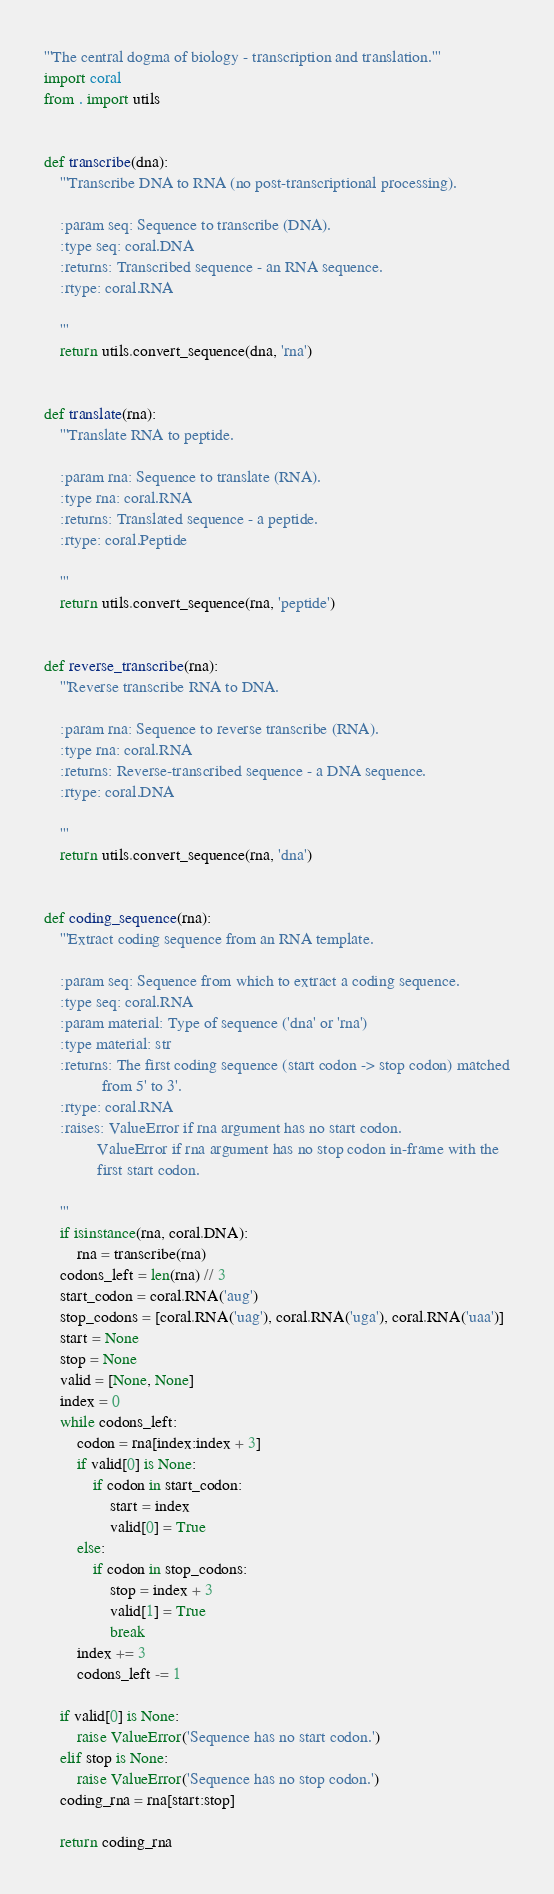<code> <loc_0><loc_0><loc_500><loc_500><_Python_>'''The central dogma of biology - transcription and translation.'''
import coral
from . import utils


def transcribe(dna):
    '''Transcribe DNA to RNA (no post-transcriptional processing).

    :param seq: Sequence to transcribe (DNA).
    :type seq: coral.DNA
    :returns: Transcribed sequence - an RNA sequence.
    :rtype: coral.RNA

    '''
    return utils.convert_sequence(dna, 'rna')


def translate(rna):
    '''Translate RNA to peptide.

    :param rna: Sequence to translate (RNA).
    :type rna: coral.RNA
    :returns: Translated sequence - a peptide.
    :rtype: coral.Peptide

    '''
    return utils.convert_sequence(rna, 'peptide')


def reverse_transcribe(rna):
    '''Reverse transcribe RNA to DNA.

    :param rna: Sequence to reverse transcribe (RNA).
    :type rna: coral.RNA
    :returns: Reverse-transcribed sequence - a DNA sequence.
    :rtype: coral.DNA

    '''
    return utils.convert_sequence(rna, 'dna')


def coding_sequence(rna):
    '''Extract coding sequence from an RNA template.

    :param seq: Sequence from which to extract a coding sequence.
    :type seq: coral.RNA
    :param material: Type of sequence ('dna' or 'rna')
    :type material: str
    :returns: The first coding sequence (start codon -> stop codon) matched
              from 5' to 3'.
    :rtype: coral.RNA
    :raises: ValueError if rna argument has no start codon.
             ValueError if rna argument has no stop codon in-frame with the
             first start codon.

    '''
    if isinstance(rna, coral.DNA):
        rna = transcribe(rna)
    codons_left = len(rna) // 3
    start_codon = coral.RNA('aug')
    stop_codons = [coral.RNA('uag'), coral.RNA('uga'), coral.RNA('uaa')]
    start = None
    stop = None
    valid = [None, None]
    index = 0
    while codons_left:
        codon = rna[index:index + 3]
        if valid[0] is None:
            if codon in start_codon:
                start = index
                valid[0] = True
        else:
            if codon in stop_codons:
                stop = index + 3
                valid[1] = True
                break
        index += 3
        codons_left -= 1

    if valid[0] is None:
        raise ValueError('Sequence has no start codon.')
    elif stop is None:
        raise ValueError('Sequence has no stop codon.')
    coding_rna = rna[start:stop]

    return coding_rna
</code> 